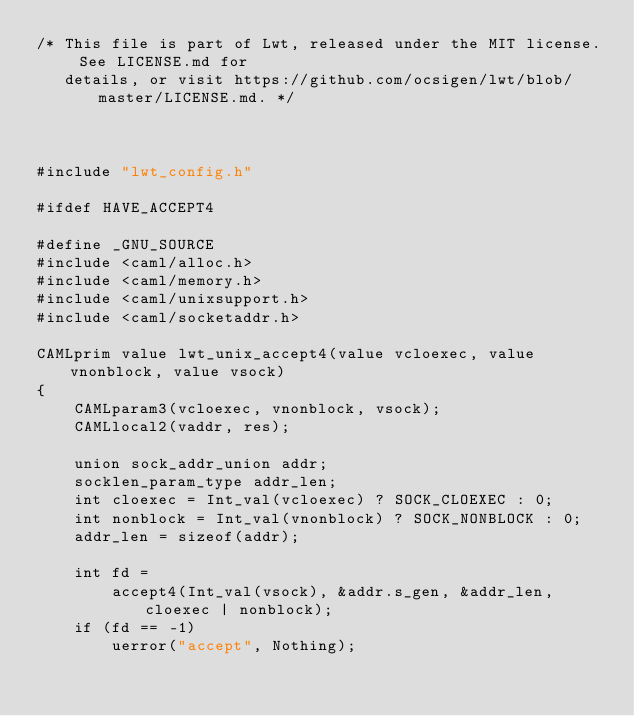<code> <loc_0><loc_0><loc_500><loc_500><_C_>/* This file is part of Lwt, released under the MIT license. See LICENSE.md for
   details, or visit https://github.com/ocsigen/lwt/blob/master/LICENSE.md. */



#include "lwt_config.h"

#ifdef HAVE_ACCEPT4

#define _GNU_SOURCE
#include <caml/alloc.h>
#include <caml/memory.h>
#include <caml/unixsupport.h>
#include <caml/socketaddr.h>

CAMLprim value lwt_unix_accept4(value vcloexec, value vnonblock, value vsock)
{
    CAMLparam3(vcloexec, vnonblock, vsock);
    CAMLlocal2(vaddr, res);

    union sock_addr_union addr;
    socklen_param_type addr_len;
    int cloexec = Int_val(vcloexec) ? SOCK_CLOEXEC : 0;
    int nonblock = Int_val(vnonblock) ? SOCK_NONBLOCK : 0;
    addr_len = sizeof(addr);

    int fd =
        accept4(Int_val(vsock), &addr.s_gen, &addr_len, cloexec | nonblock);
    if (fd == -1)
        uerror("accept", Nothing);
</code> 